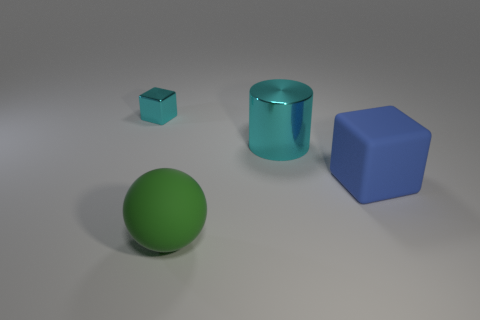Subtract all red balls. Subtract all yellow cylinders. How many balls are left? 1 Subtract all yellow blocks. How many yellow cylinders are left? 0 Subtract all large blue things. Subtract all large blue rubber blocks. How many objects are left? 2 Add 3 cylinders. How many cylinders are left? 4 Add 1 spheres. How many spheres exist? 2 Add 2 cyan shiny objects. How many objects exist? 6 Subtract 0 blue balls. How many objects are left? 4 Subtract all cylinders. How many objects are left? 3 